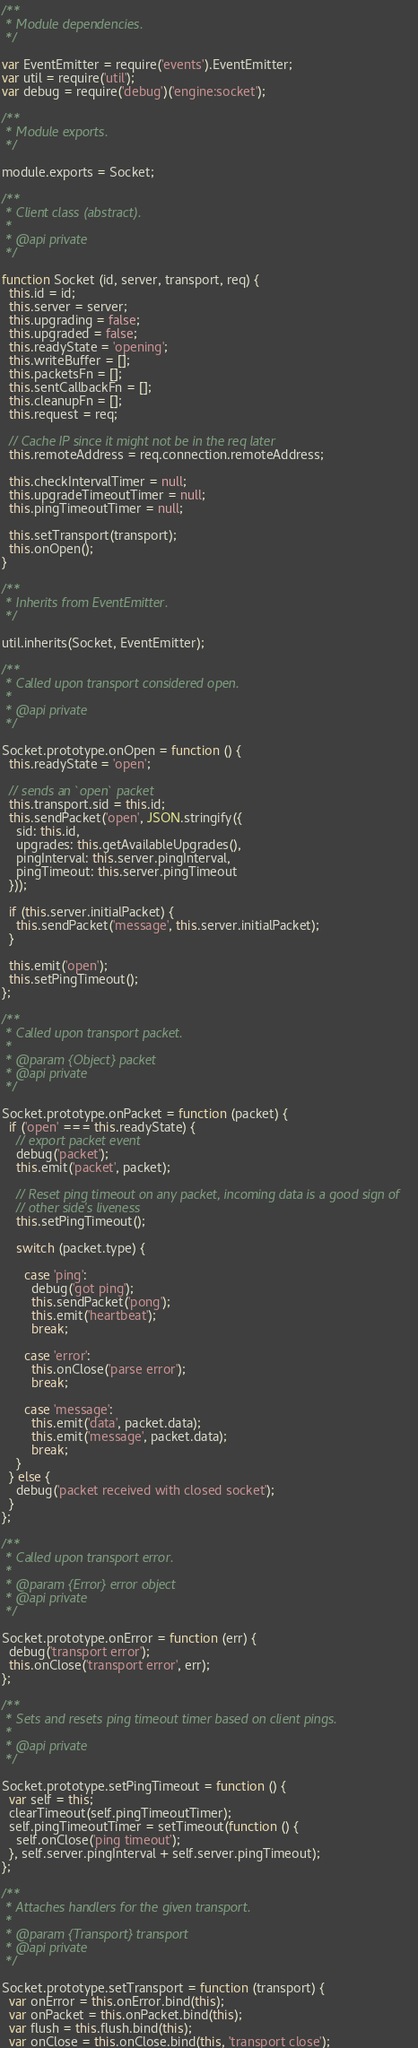Convert code to text. <code><loc_0><loc_0><loc_500><loc_500><_JavaScript_>/**
 * Module dependencies.
 */

var EventEmitter = require('events').EventEmitter;
var util = require('util');
var debug = require('debug')('engine:socket');

/**
 * Module exports.
 */

module.exports = Socket;

/**
 * Client class (abstract).
 *
 * @api private
 */

function Socket (id, server, transport, req) {
  this.id = id;
  this.server = server;
  this.upgrading = false;
  this.upgraded = false;
  this.readyState = 'opening';
  this.writeBuffer = [];
  this.packetsFn = [];
  this.sentCallbackFn = [];
  this.cleanupFn = [];
  this.request = req;

  // Cache IP since it might not be in the req later
  this.remoteAddress = req.connection.remoteAddress;

  this.checkIntervalTimer = null;
  this.upgradeTimeoutTimer = null;
  this.pingTimeoutTimer = null;

  this.setTransport(transport);
  this.onOpen();
}

/**
 * Inherits from EventEmitter.
 */

util.inherits(Socket, EventEmitter);

/**
 * Called upon transport considered open.
 *
 * @api private
 */

Socket.prototype.onOpen = function () {
  this.readyState = 'open';

  // sends an `open` packet
  this.transport.sid = this.id;
  this.sendPacket('open', JSON.stringify({
    sid: this.id,
    upgrades: this.getAvailableUpgrades(),
    pingInterval: this.server.pingInterval,
    pingTimeout: this.server.pingTimeout
  }));

  if (this.server.initialPacket) {
    this.sendPacket('message', this.server.initialPacket);
  }

  this.emit('open');
  this.setPingTimeout();
};

/**
 * Called upon transport packet.
 *
 * @param {Object} packet
 * @api private
 */

Socket.prototype.onPacket = function (packet) {
  if ('open' === this.readyState) {
    // export packet event
    debug('packet');
    this.emit('packet', packet);

    // Reset ping timeout on any packet, incoming data is a good sign of
    // other side's liveness
    this.setPingTimeout();

    switch (packet.type) {

      case 'ping':
        debug('got ping');
        this.sendPacket('pong');
        this.emit('heartbeat');
        break;

      case 'error':
        this.onClose('parse error');
        break;

      case 'message':
        this.emit('data', packet.data);
        this.emit('message', packet.data);
        break;
    }
  } else {
    debug('packet received with closed socket');
  }
};

/**
 * Called upon transport error.
 *
 * @param {Error} error object
 * @api private
 */

Socket.prototype.onError = function (err) {
  debug('transport error');
  this.onClose('transport error', err);
};

/**
 * Sets and resets ping timeout timer based on client pings.
 *
 * @api private
 */

Socket.prototype.setPingTimeout = function () {
  var self = this;
  clearTimeout(self.pingTimeoutTimer);
  self.pingTimeoutTimer = setTimeout(function () {
    self.onClose('ping timeout');
  }, self.server.pingInterval + self.server.pingTimeout);
};

/**
 * Attaches handlers for the given transport.
 *
 * @param {Transport} transport
 * @api private
 */

Socket.prototype.setTransport = function (transport) {
  var onError = this.onError.bind(this);
  var onPacket = this.onPacket.bind(this);
  var flush = this.flush.bind(this);
  var onClose = this.onClose.bind(this, 'transport close');
</code> 